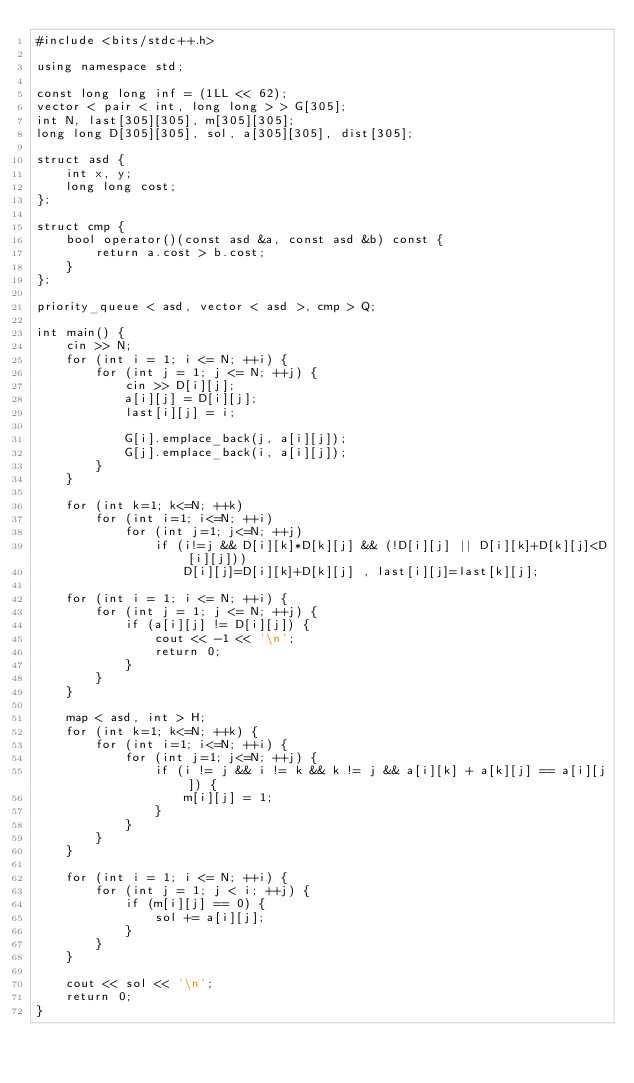Convert code to text. <code><loc_0><loc_0><loc_500><loc_500><_C++_>#include <bits/stdc++.h>

using namespace std;

const long long inf = (1LL << 62);
vector < pair < int, long long > > G[305];
int N, last[305][305], m[305][305];
long long D[305][305], sol, a[305][305], dist[305];

struct asd {
    int x, y;
    long long cost;
};

struct cmp {
    bool operator()(const asd &a, const asd &b) const {
        return a.cost > b.cost;
    }
};

priority_queue < asd, vector < asd >, cmp > Q;

int main() {
    cin >> N;
    for (int i = 1; i <= N; ++i) {
        for (int j = 1; j <= N; ++j) {
            cin >> D[i][j];
            a[i][j] = D[i][j];
            last[i][j] = i;
            
            G[i].emplace_back(j, a[i][j]);
            G[j].emplace_back(i, a[i][j]);
        }
    }
    
    for (int k=1; k<=N; ++k)
        for (int i=1; i<=N; ++i)
            for (int j=1; j<=N; ++j)
                if (i!=j && D[i][k]*D[k][j] && (!D[i][j] || D[i][k]+D[k][j]<D[i][j]))
                    D[i][j]=D[i][k]+D[k][j] , last[i][j]=last[k][j];
                    
    for (int i = 1; i <= N; ++i) {
        for (int j = 1; j <= N; ++j) {
            if (a[i][j] != D[i][j]) {
                cout << -1 << '\n';
                return 0;
            }
        }
    }
    
    map < asd, int > H;
    for (int k=1; k<=N; ++k) {
        for (int i=1; i<=N; ++i) {
            for (int j=1; j<=N; ++j) {
                if (i != j && i != k && k != j && a[i][k] + a[k][j] == a[i][j]) {
                    m[i][j] = 1;
                }
            }
        }
    }
    
    for (int i = 1; i <= N; ++i) {
        for (int j = 1; j < i; ++j) {
            if (m[i][j] == 0) {
                sol += a[i][j];
            }
        }
    }
    
    cout << sol << '\n';
    return 0;
}</code> 